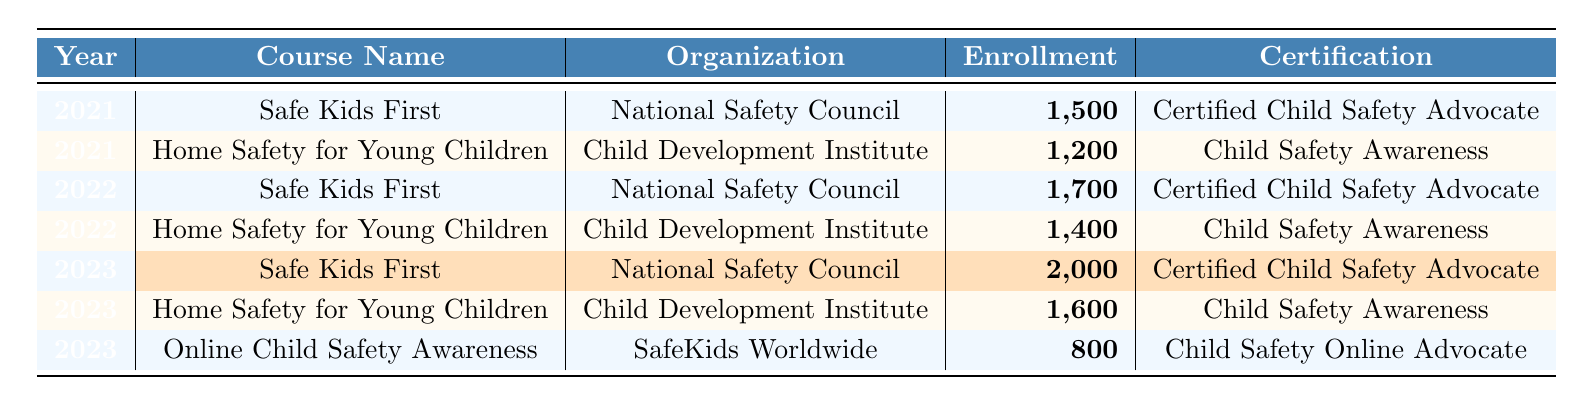What is the enrollment number for "Safe Kids First" in 2023? The table shows that in 2023, the enrollment number for the "Safe Kids First" course is highlighted, which indicates a value of 2,000.
Answer: 2,000 What was the enrollment number for "Home Safety for Young Children" in 2022? Referring to the table, the enrollment number for "Home Safety for Young Children" in 2022 is found, which is 1,400.
Answer: 1,400 Which organization conducted the "Online Child Safety Awareness" course? The table provides the organization name associated with the "Online Child Safety Awareness" course, which is "SafeKids Worldwide."
Answer: SafeKids Worldwide In which year did "Safe Kids First" see the highest enrollment? By examining the enrollment numbers for "Safe Kids First" across the years, it had 1,500 in 2021, 1,700 in 2022, and 2,000 in 2023. The highest enrollment was in 2023.
Answer: 2023 What is the difference in enrollment numbers between the "Home Safety for Young Children" course in 2021 and 2023? The enrollment numbers for "Home Safety for Young Children" are 1,200 in 2021 and 1,600 in 2023. The difference is calculated as 1,600 - 1,200 = 400.
Answer: 400 What was the total enrollment across all courses in 2023? Summing the enrollment numbers for all courses in 2023: 2,000 (Safe Kids First) + 1,600 (Home Safety for Young Children) + 800 (Online Child Safety Awareness) results in a total of 4,400.
Answer: 4,400 Was the enrollment for "Home Safety for Young Children" higher in 2022 than in 2021? The enrollment for "Home Safety for Young Children" was 1,200 in 2021 and 1,400 in 2022. Since 1,400 is greater than 1,200, the answer is yes.
Answer: Yes What is the average enrollment number for the courses over the three years? The total enrollment over the three years is calculated as follows: 1,500 + 1,200 (2021) + 1,700 + 1,400 (2022) + 2,000 + 1,600 + 800 (2023) = 10,200. There are 7 data points, so the average is 10,200 / 7 = 1,457.14 (approx.).
Answer: 1,457.14 How many courses are offered by the "National Safety Council"? The table shows that the "National Safety Council" offers the "Safe Kids First" course for all three years, resulting in a total of 3 course offerings.
Answer: 3 